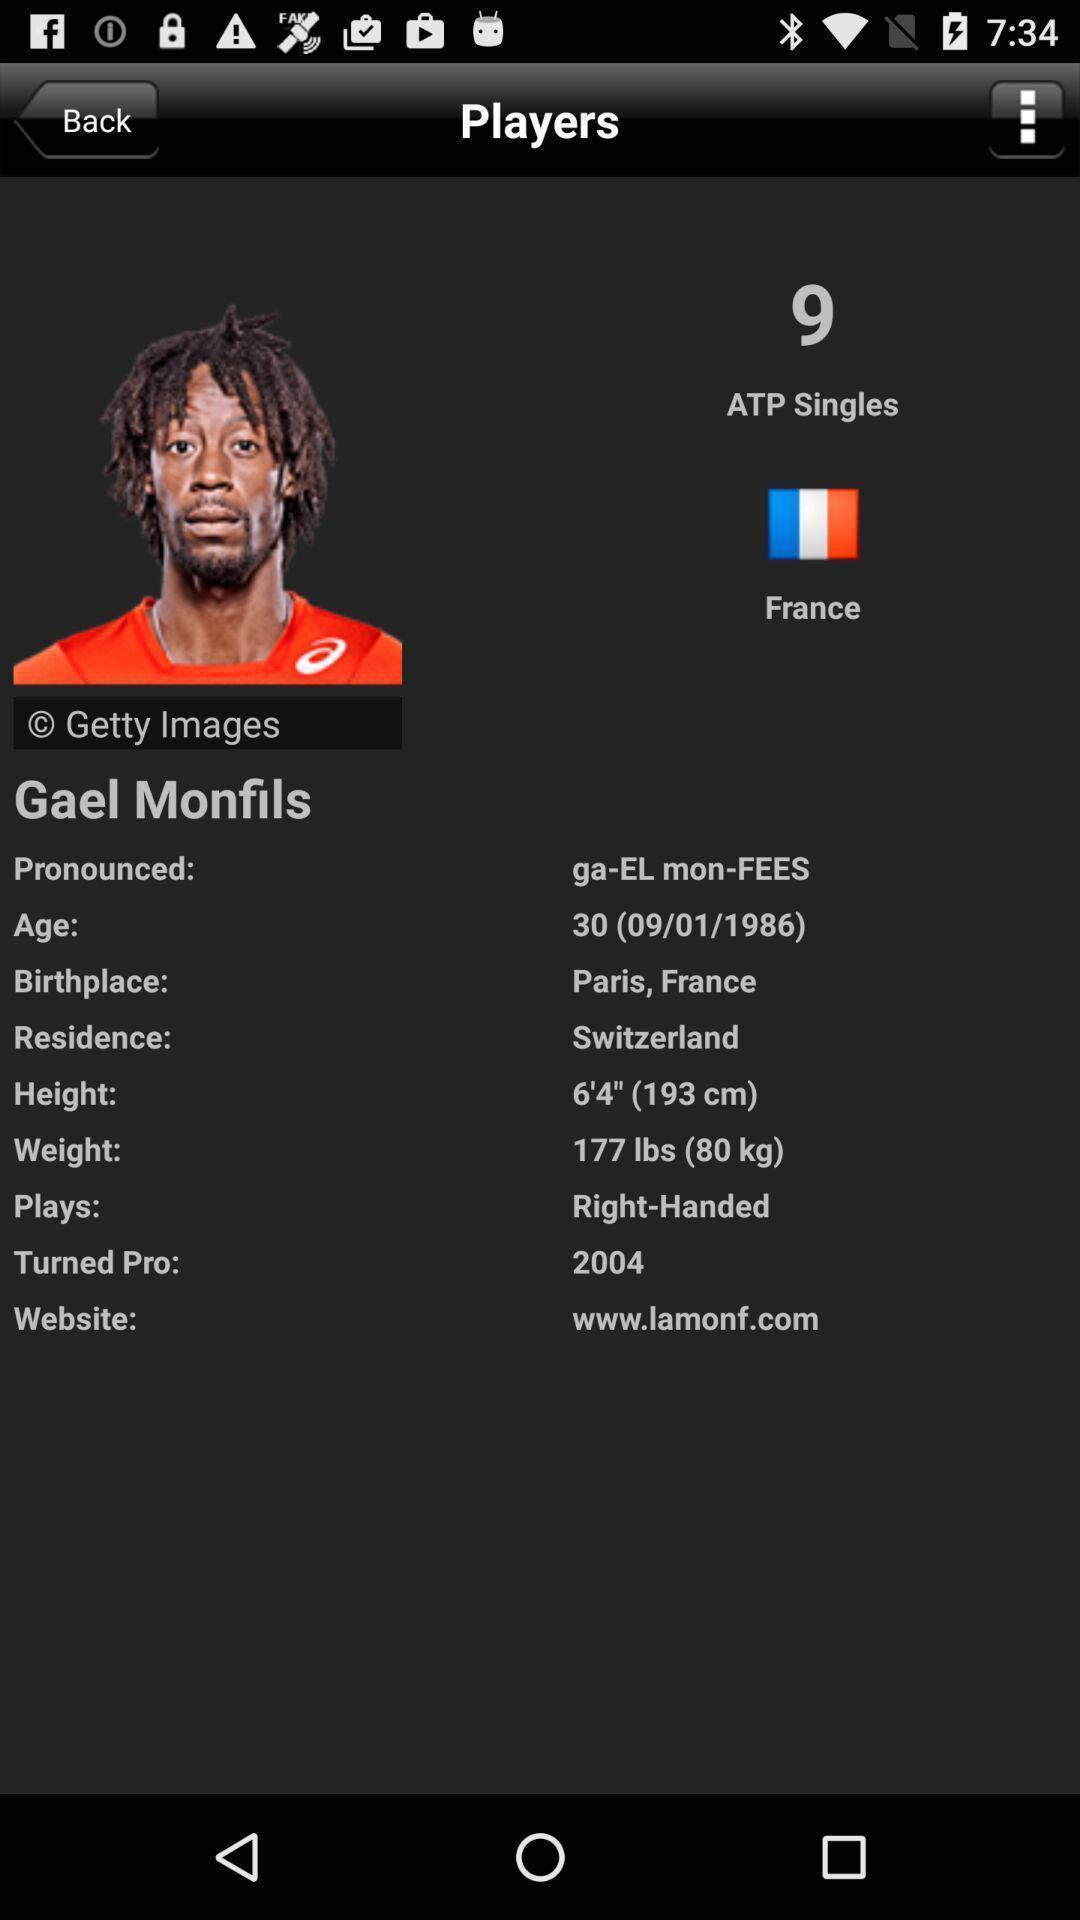Give me a narrative description of this picture. Players of live scoring app. 